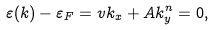Convert formula to latex. <formula><loc_0><loc_0><loc_500><loc_500>\varepsilon ( k ) - \varepsilon _ { F } = v k _ { x } + A k _ { y } ^ { n } = 0 ,</formula> 